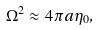Convert formula to latex. <formula><loc_0><loc_0><loc_500><loc_500>\Omega ^ { 2 } \approx 4 \pi a \eta _ { 0 } ,</formula> 